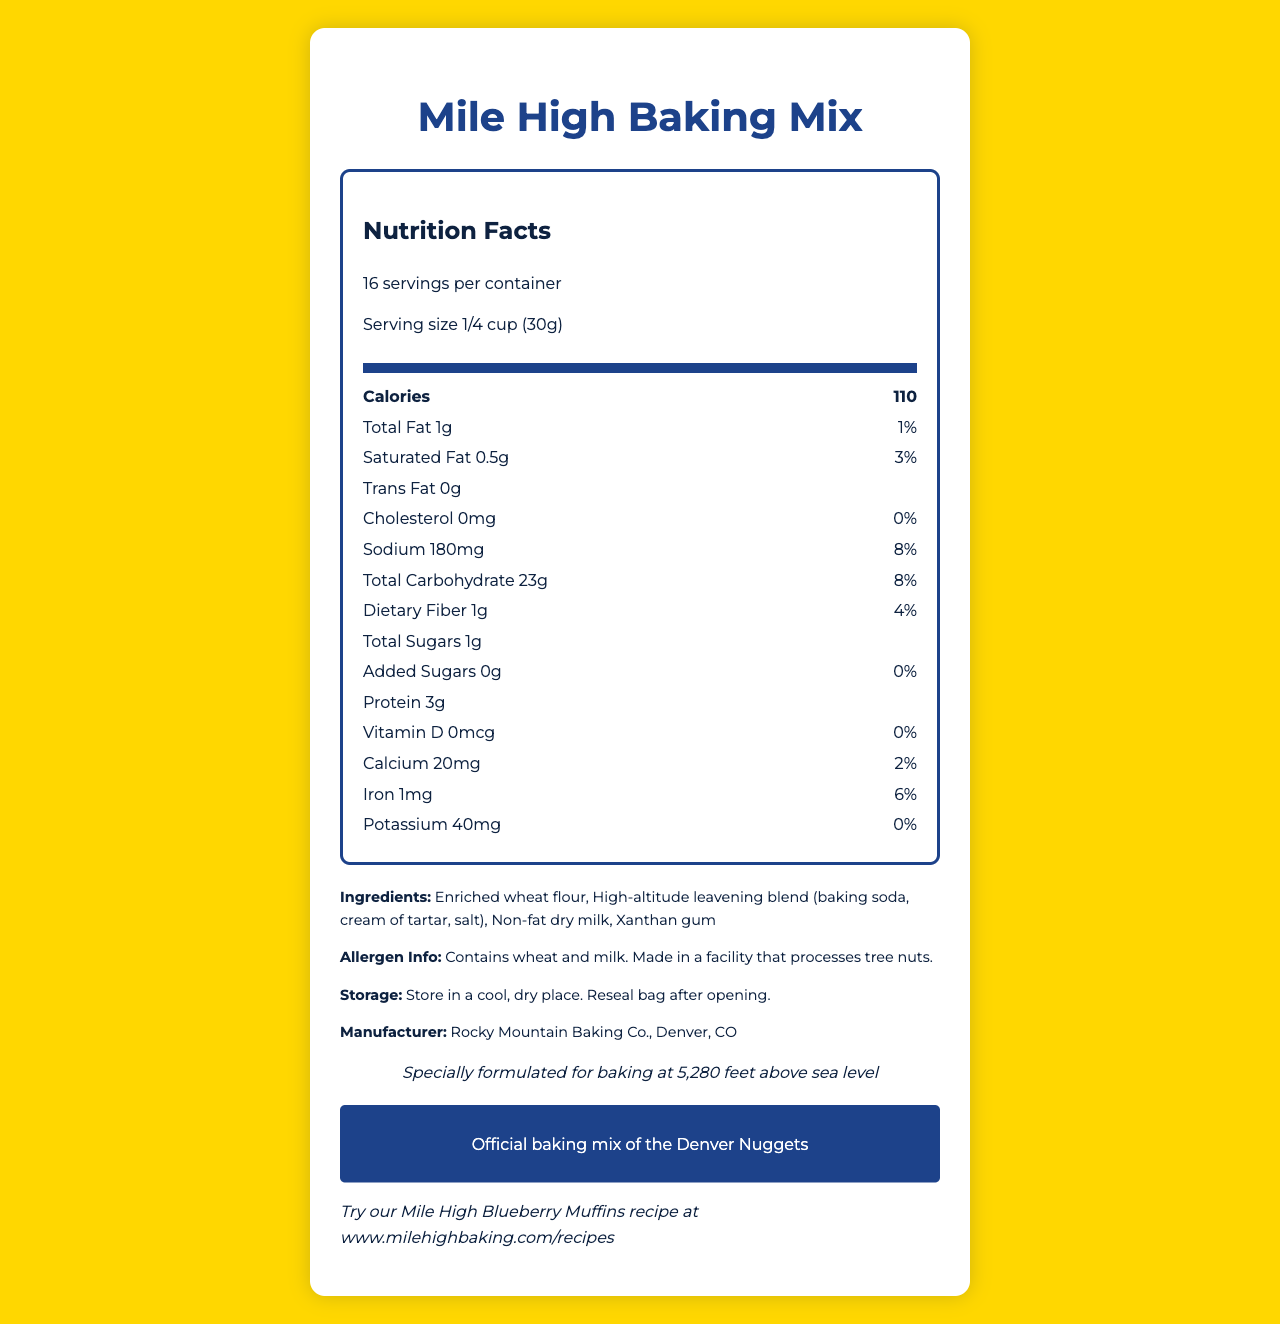what is the serving size? The serving size is explicitly mentioned in the document.
Answer: 1/4 cup (30g) how many servings are in the container? The document states that there are 16 servings per container.
Answer: 16 how many calories are there per serving? The document lists 110 calories per serving in the Nutrition Facts section.
Answer: 110 how much protein is in one serving? The amount of protein per serving is clearly listed as 3g in the nutrition label.
Answer: 3g what ingredients are used in this baking mix? The ingredients are listed in the "Ingredients" section of the document.
Answer: Enriched wheat flour, High-altitude leavening blend (baking soda, cream of tartar, salt), Non-fat dry milk, Xanthan gum how much dietary fiber is there per serving? The document states that there is 1g of dietary fiber per serving.
Answer: 1g what is the daily value percentage of iron? The daily value percentage of iron is shown as 6% in the nutrition label.
Answer: 6% how much sodium does one serving contain? The sodium content per serving is listed as 180mg.
Answer: 180mg what company manufactures this product? The manufacturer is stated in the "Manufacturer" section of the document.
Answer: Rocky Mountain Baking Co., Denver, CO what is the official baking mix of the Denver Nuggets? The "nuggets_promo" section mentions that this is the official baking mix of the Denver Nuggets.
Answer: Mile High Baking Mix what are the storage instructions for this product? The "storage_instructions" section provides these details.
Answer: Store in a cool, dry place. Reseal bag after opening. what is the main idea of this document? The document is focused on presenting comprehensive details about the Mile High Baking Mix, including its suitability for high-altitude baking at Denver's elevation.
Answer: The document provides nutritional information, ingredients, allergen details, storage instructions, and promotional information for the Mile High Baking Mix, specifically formulated for high-altitude baking in Denver. how many grams of trans fat are in this baking mix per serving? The document lists 0g of trans fat per serving.
Answer: 0g how much calcium is in one serving? The calcium content per serving is displayed as 20mg in the nutrition label.
Answer: 20mg Can this product be safely consumed by someone with a nut allergy? While it's stated that the product is made in a facility that processes tree nuts, it cannot be conclusively determined if the product is completely safe for someone with a nut allergy based on the provided information.
Answer: Not enough information what allergens are present in this product? A. Wheat B. Milk C. Soy D. Tree nuts The allergen information states that the product contains wheat and milk, and is made in a facility that processes tree nuts.
Answer: A. Wheat B. Milk what is the daily value percentage of total carbohydrates? A. 7% B. 6% C. 8% D. 9% The daily value percentage of total carbohydrates is listed as 8%.
Answer: C. 8% is there any added sugar in this product? The nutrition label shows 0g of added sugars per serving, which indicates that no added sugar is present.
Answer: No is this baking mix suitable for high-altitude baking? The document notes that the product is specially formulated for baking at 5,280 feet above sea level.
Answer: Yes what promotional message is associated with this product? The "nuggets_promo" section clearly states this promotional message.
Answer: Official baking mix of the Denver Nuggets 